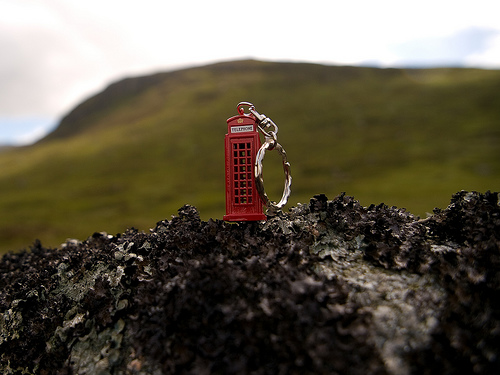<image>
Is the keychain on the grass? No. The keychain is not positioned on the grass. They may be near each other, but the keychain is not supported by or resting on top of the grass. Is there a keychain in front of the hill? Yes. The keychain is positioned in front of the hill, appearing closer to the camera viewpoint. 